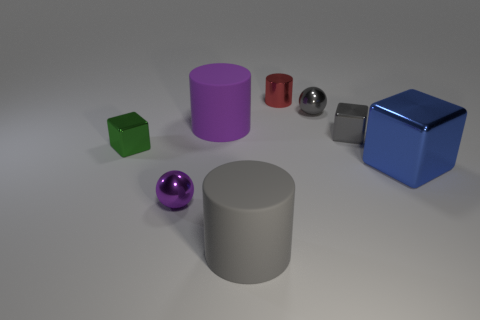Add 2 green things. How many objects exist? 10 Subtract all big gray cylinders. How many cylinders are left? 2 Subtract all cubes. How many objects are left? 5 Subtract all purple cylinders. How many cylinders are left? 2 Subtract 2 cubes. How many cubes are left? 1 Subtract all purple cylinders. Subtract all gray cubes. How many cylinders are left? 2 Subtract all gray cylinders. How many gray blocks are left? 1 Subtract all small green shiny blocks. Subtract all small metal blocks. How many objects are left? 5 Add 6 tiny green things. How many tiny green things are left? 7 Add 6 small red metal things. How many small red metal things exist? 7 